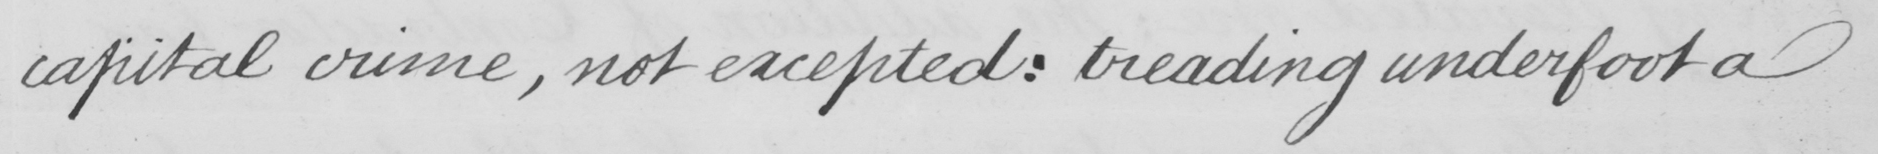Can you read and transcribe this handwriting? capital crime , not excepted :  treading underfoot a 